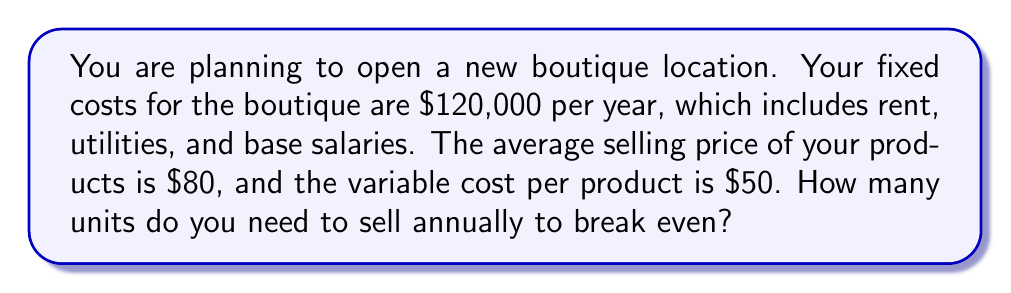Show me your answer to this math problem. To calculate the break-even point, we need to determine the number of units that must be sold for total revenue to equal total costs. Let's break this down step-by-step:

1. Define the variables:
   Let $x$ = number of units sold
   Fixed costs (FC) = $120,000
   Selling price per unit (P) = $80
   Variable cost per unit (V) = $50

2. Set up the break-even equation:
   Total Revenue = Total Costs
   $Px = FC + Vx$

3. Substitute the known values:
   $80x = 120,000 + 50x$

4. Solve for $x$:
   $80x - 50x = 120,000$
   $30x = 120,000$
   
   $$x = \frac{120,000}{30} = 4,000$$

5. Verify the result:
   At 4,000 units:
   Total Revenue = $80 * 4,000 = $320,000
   Total Costs = $120,000 + ($50 * 4,000) = $320,000

   Revenue equals costs, confirming the break-even point.

The break-even point occurs when 4,000 units are sold annually. This means you need to sell an average of approximately 11 units per day (assuming a 365-day year) to cover all costs.
Answer: 4,000 units 